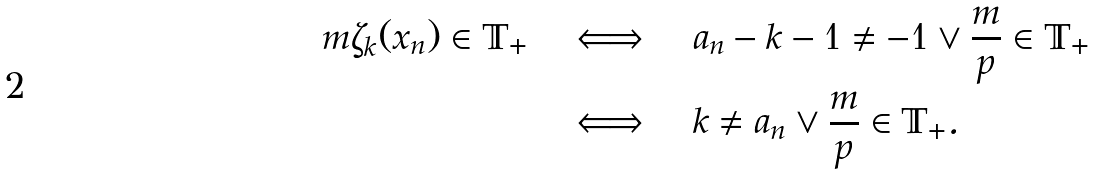<formula> <loc_0><loc_0><loc_500><loc_500>m \zeta _ { k } ( x _ { n } ) \in \mathbb { T } _ { + } \quad & \Longleftrightarrow \quad a _ { n } - k - 1 \neq - 1 \vee \frac { m } { p } \in \mathbb { T } _ { + } \\ & \Longleftrightarrow \quad k \neq a _ { n } \vee \frac { m } { p } \in \mathbb { T } _ { + } .</formula> 